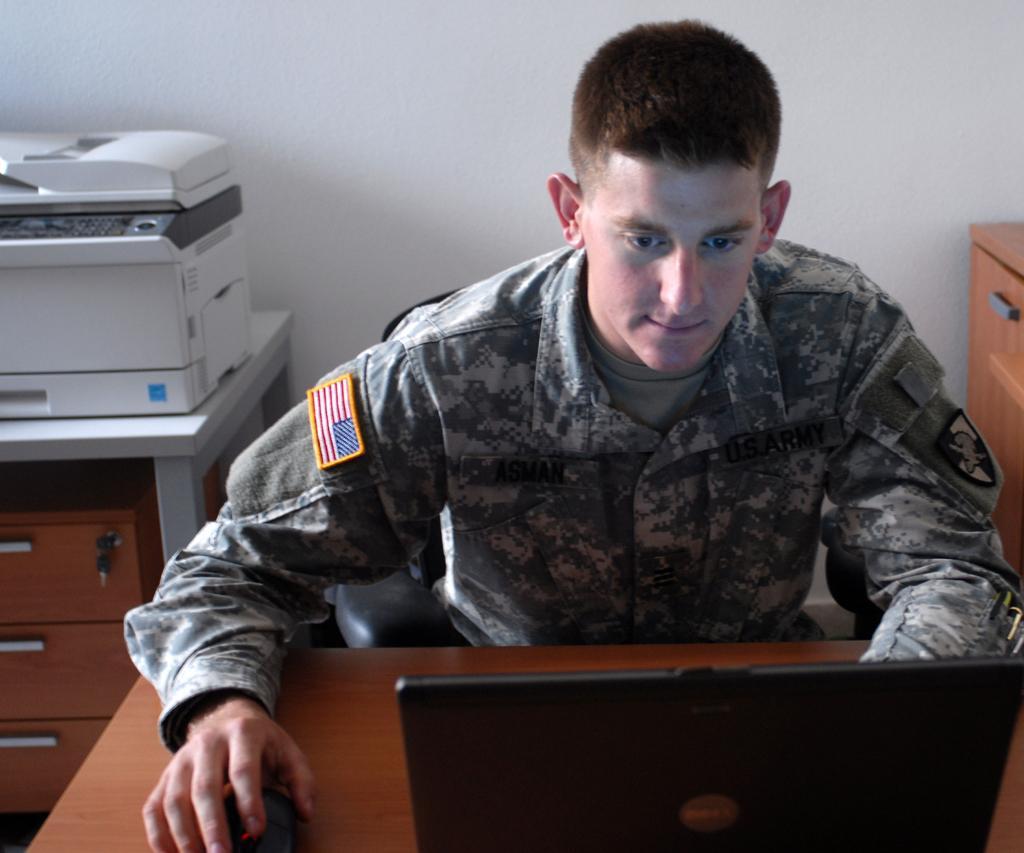How would you summarize this image in a sentence or two? In this image there is a person wearing military dress operating laptop and at the background of the image there is a printer and wall. 